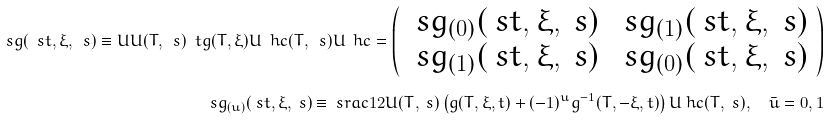<formula> <loc_0><loc_0><loc_500><loc_500>\ s g ( \ s t , \xi , \ s ) \equiv U U ( T , \ s ) \ t g ( T , \xi ) U \ h c ( T , \ s ) U \ h c = \left ( \begin{array} { c c } \ s g _ { ( 0 ) } ( \ s t , \xi , \ s ) & \ s g _ { ( 1 ) } ( \ s t , \xi , \ s ) \\ \ s g _ { ( 1 ) } ( \ s t , \xi , \ s ) & \ s g _ { ( 0 ) } ( \ s t , \xi , \ s ) \end{array} \right ) \\ \ s g _ { ( u ) } ( \ s t , \xi , \ s ) \equiv \ s r a c { 1 } { 2 } U ( T , \ s ) \left ( g ( T , \xi , t ) + ( - 1 ) ^ { u } g ^ { - 1 } ( T , - \xi , t ) \right ) U \ h c ( T , \ s ) , \quad \bar { u } = 0 , 1</formula> 